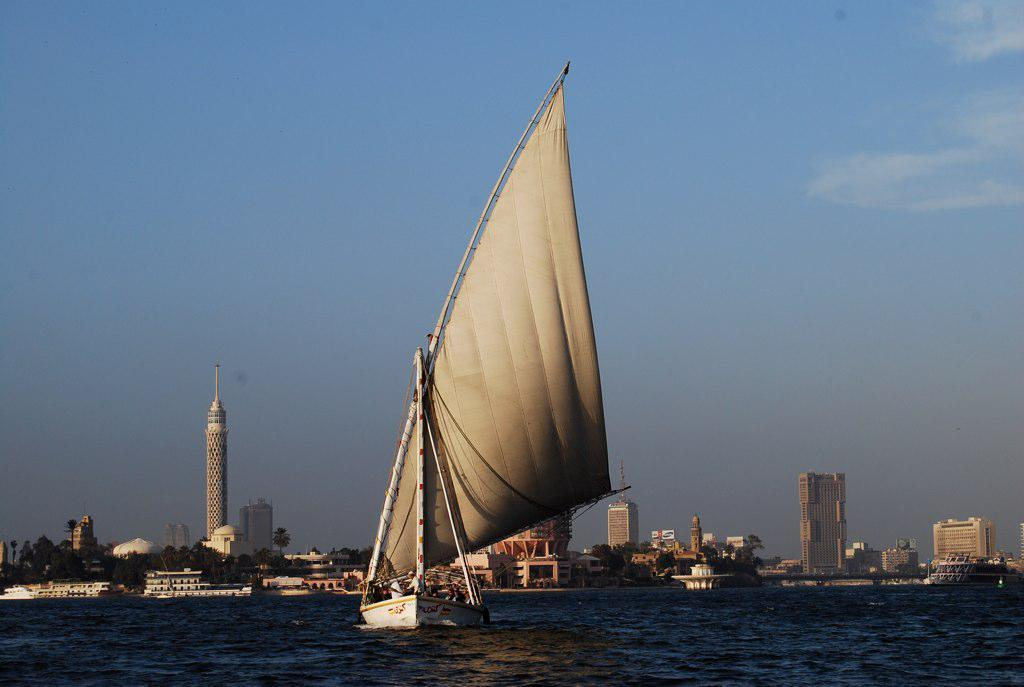What is the main subject of the image? The main subject of the image is a boat. Where is the boat located? The boat is on the water. What can be seen in the background of the image? There are trees, buildings, and the sky visible in the background of the image. What type of insurance policy is being discussed by the people on the boat in the image? There are no people visible in the image, and no insurance policy is being discussed. 